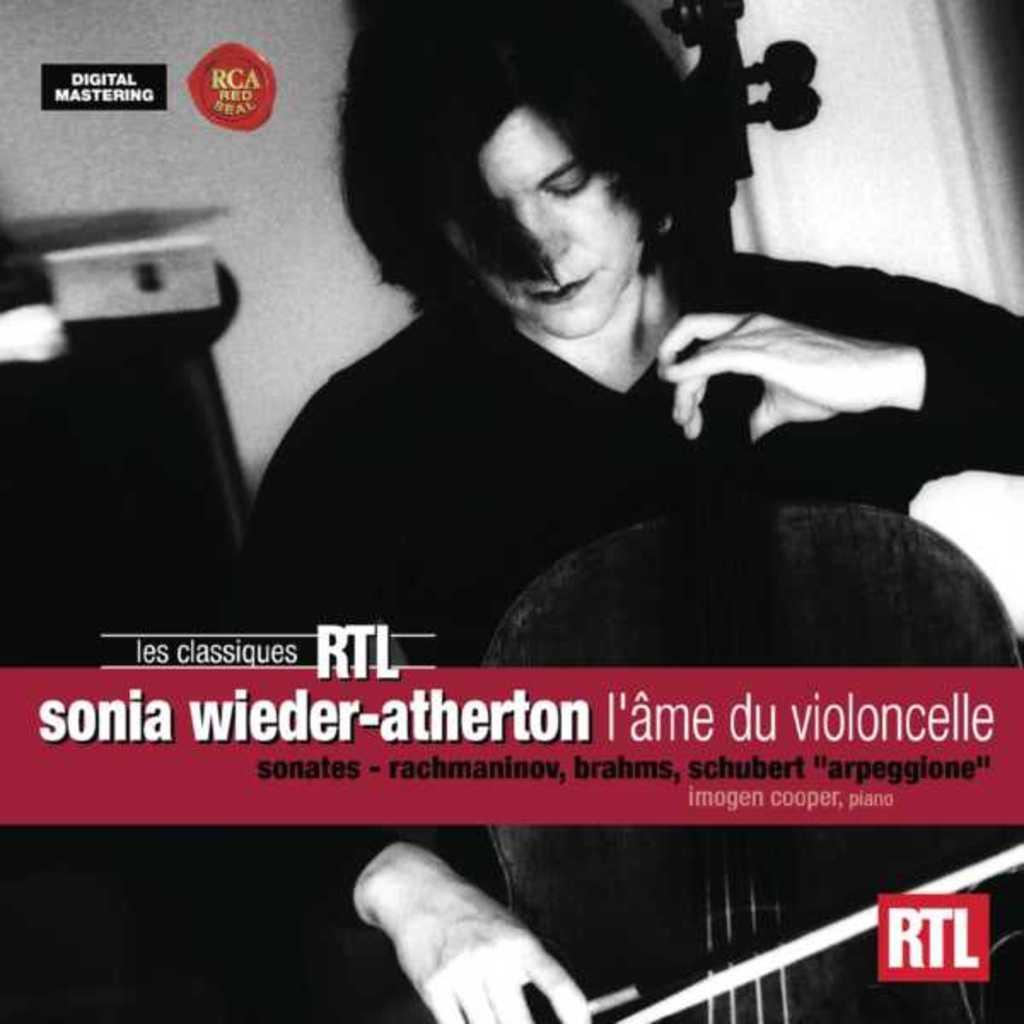How would you summarize this image in a sentence or two? This is a black and white image. In this image there is a person playing a violin. Also something is written on the image. 